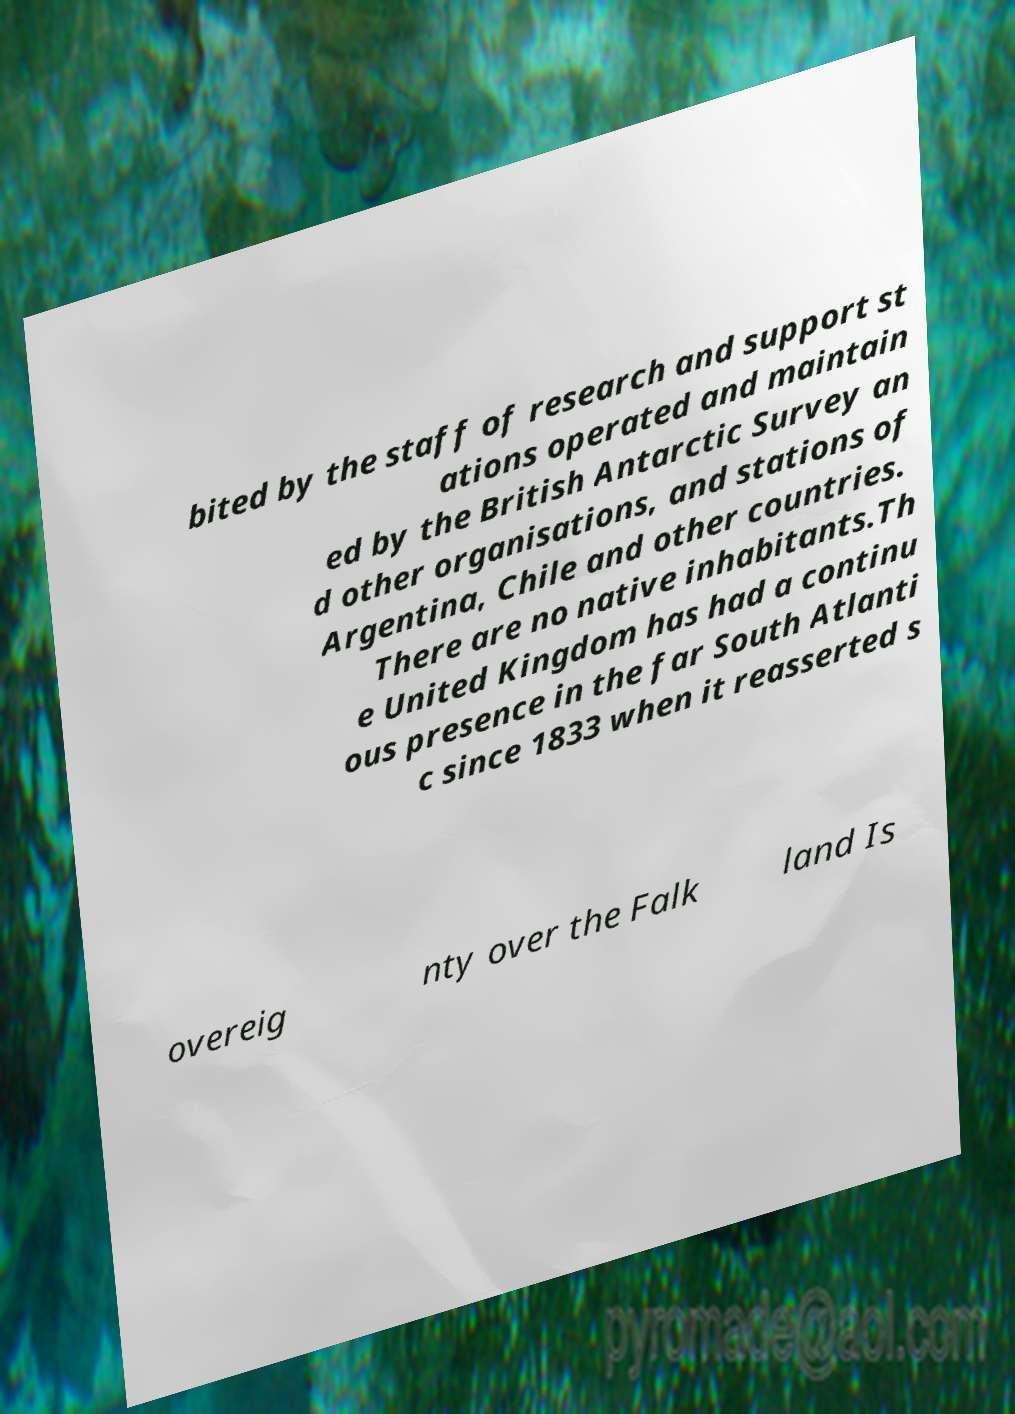For documentation purposes, I need the text within this image transcribed. Could you provide that? bited by the staff of research and support st ations operated and maintain ed by the British Antarctic Survey an d other organisations, and stations of Argentina, Chile and other countries. There are no native inhabitants.Th e United Kingdom has had a continu ous presence in the far South Atlanti c since 1833 when it reasserted s overeig nty over the Falk land Is 